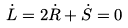<formula> <loc_0><loc_0><loc_500><loc_500>\dot { L } = 2 \dot { R } + \dot { S } = 0</formula> 